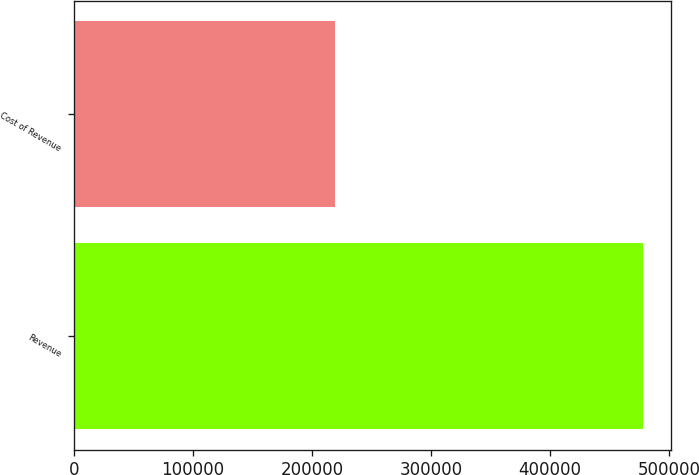<chart> <loc_0><loc_0><loc_500><loc_500><bar_chart><fcel>Revenue<fcel>Cost of Revenue<nl><fcel>477605<fcel>219440<nl></chart> 